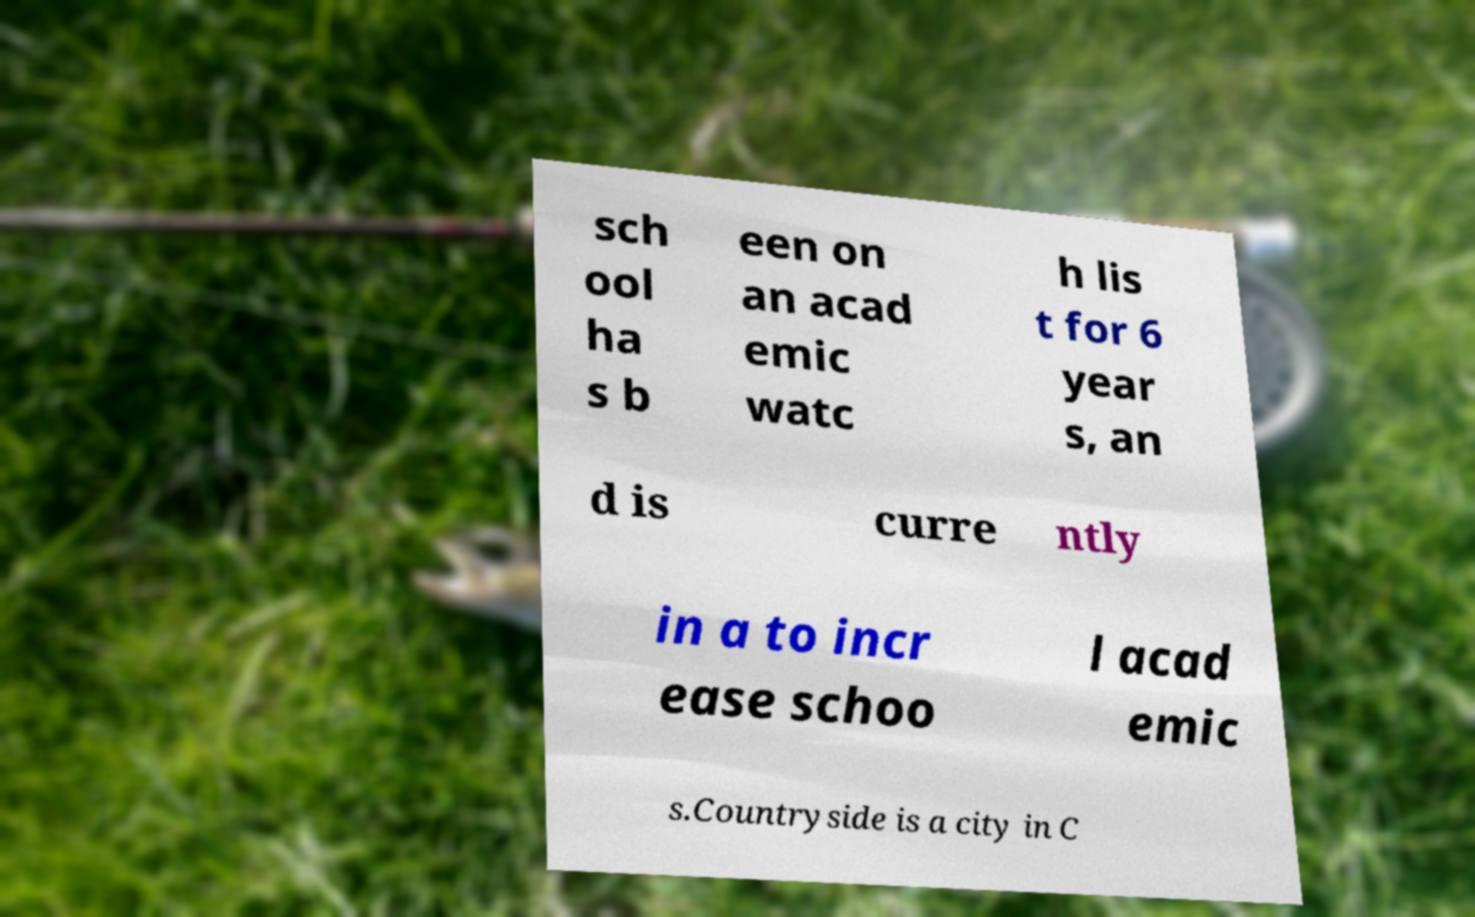For documentation purposes, I need the text within this image transcribed. Could you provide that? sch ool ha s b een on an acad emic watc h lis t for 6 year s, an d is curre ntly in a to incr ease schoo l acad emic s.Countryside is a city in C 